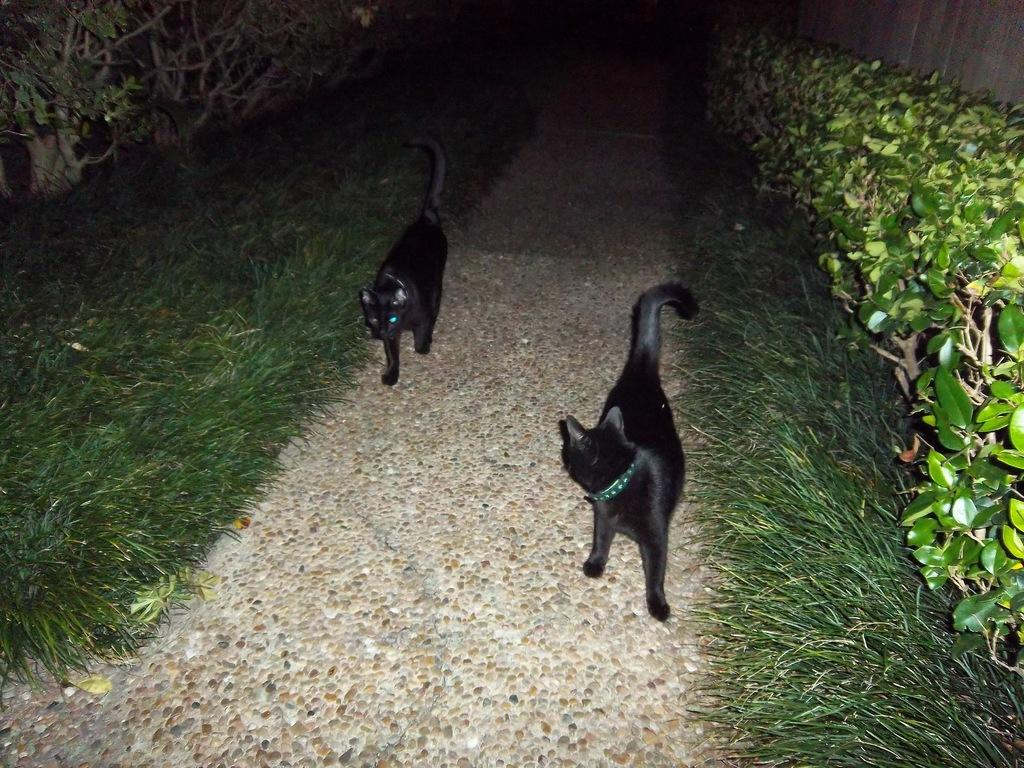How many cats are present in the image? There are two cats in the image. What are the cats doing in the image? The cats are walking on a path. What type of vegetation is present on either side of the path? There is grass on either side of the path. What else can be seen on the ground near the path? There are plants on the ground near the path. What type of wine is being served at the event in the image? There is no event or wine present in the image; it features two cats walking on a path surrounded by grass and plants. 